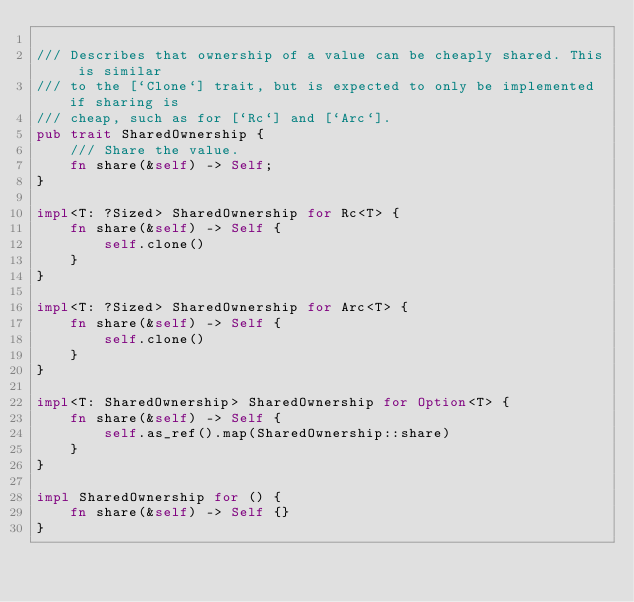<code> <loc_0><loc_0><loc_500><loc_500><_Rust_>
/// Describes that ownership of a value can be cheaply shared. This is similar
/// to the [`Clone`] trait, but is expected to only be implemented if sharing is
/// cheap, such as for [`Rc`] and [`Arc`].
pub trait SharedOwnership {
    /// Share the value.
    fn share(&self) -> Self;
}

impl<T: ?Sized> SharedOwnership for Rc<T> {
    fn share(&self) -> Self {
        self.clone()
    }
}

impl<T: ?Sized> SharedOwnership for Arc<T> {
    fn share(&self) -> Self {
        self.clone()
    }
}

impl<T: SharedOwnership> SharedOwnership for Option<T> {
    fn share(&self) -> Self {
        self.as_ref().map(SharedOwnership::share)
    }
}

impl SharedOwnership for () {
    fn share(&self) -> Self {}
}
</code> 